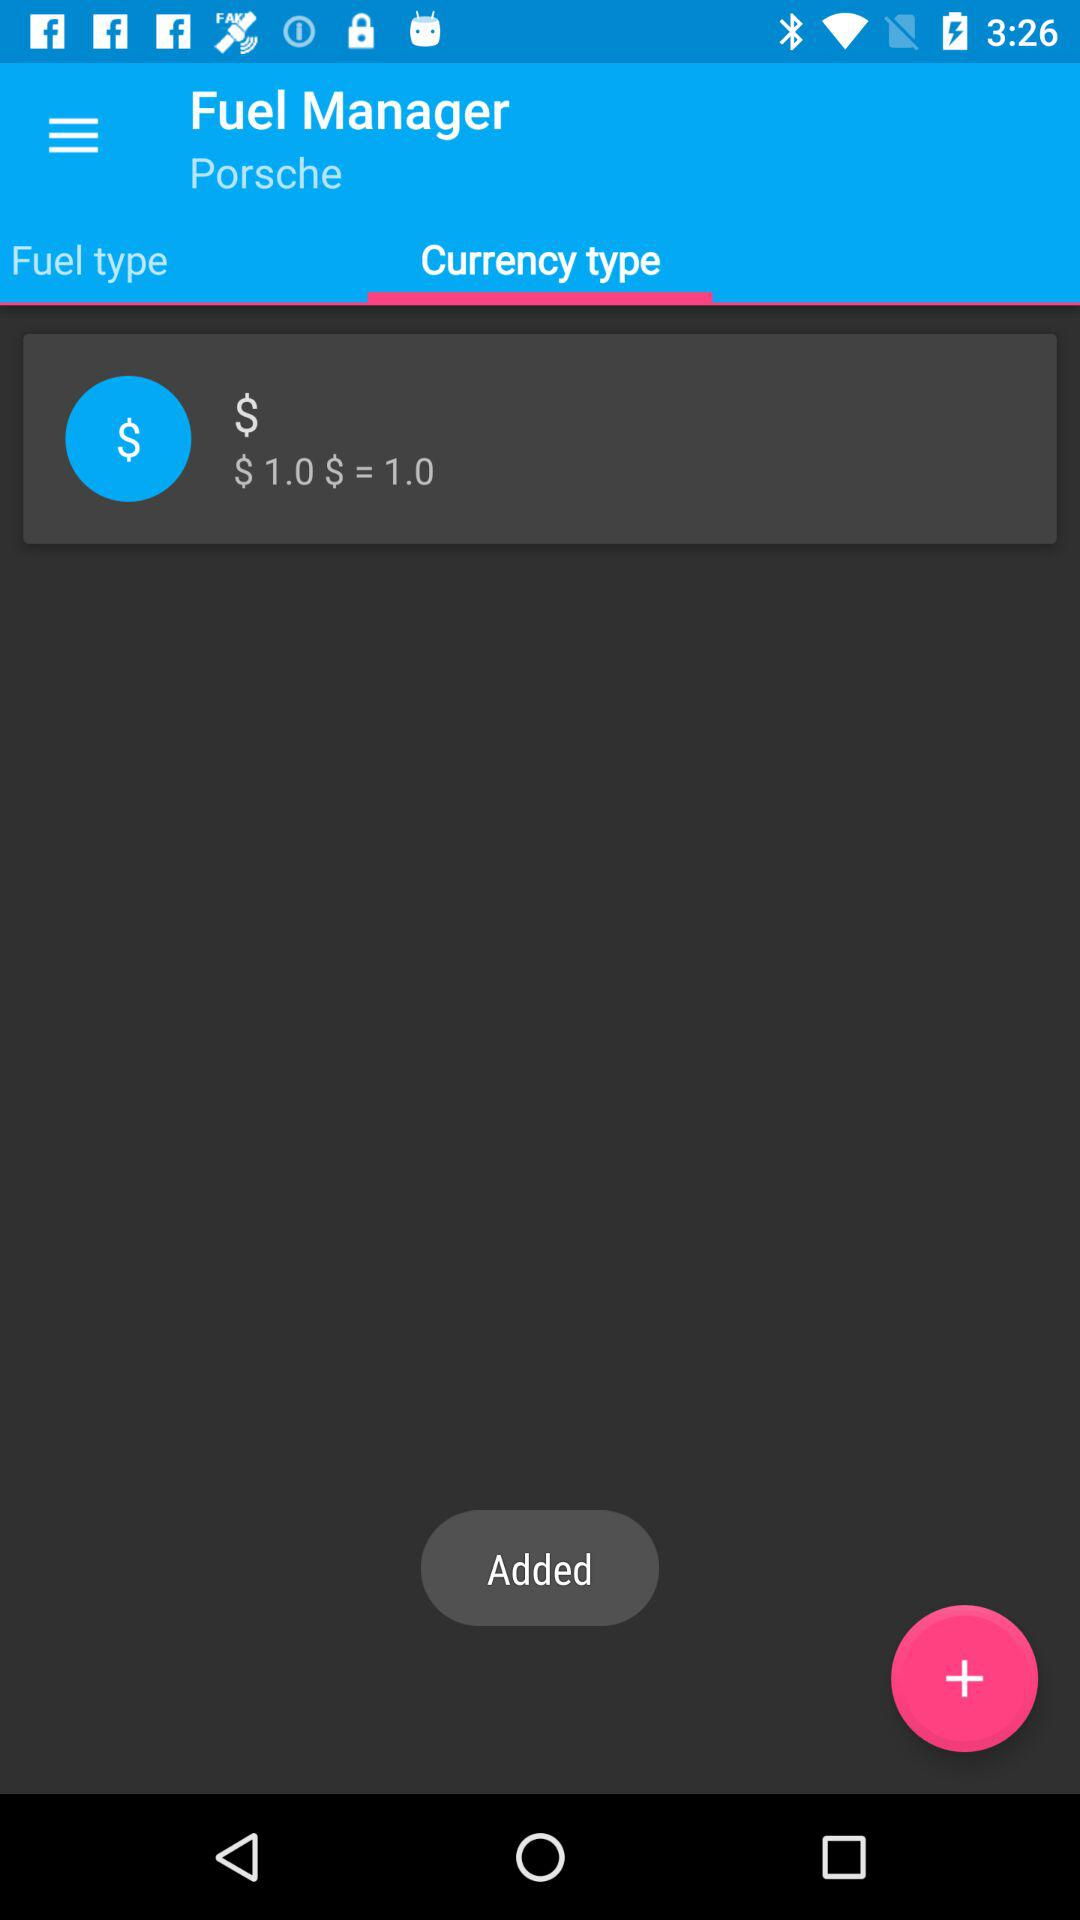Which tab is selected? The selected tab is "Currency type". 